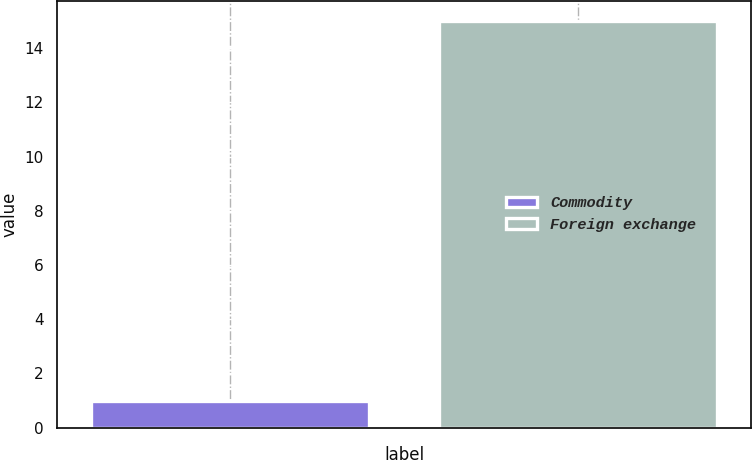Convert chart. <chart><loc_0><loc_0><loc_500><loc_500><bar_chart><fcel>Commodity<fcel>Foreign exchange<nl><fcel>1<fcel>15<nl></chart> 